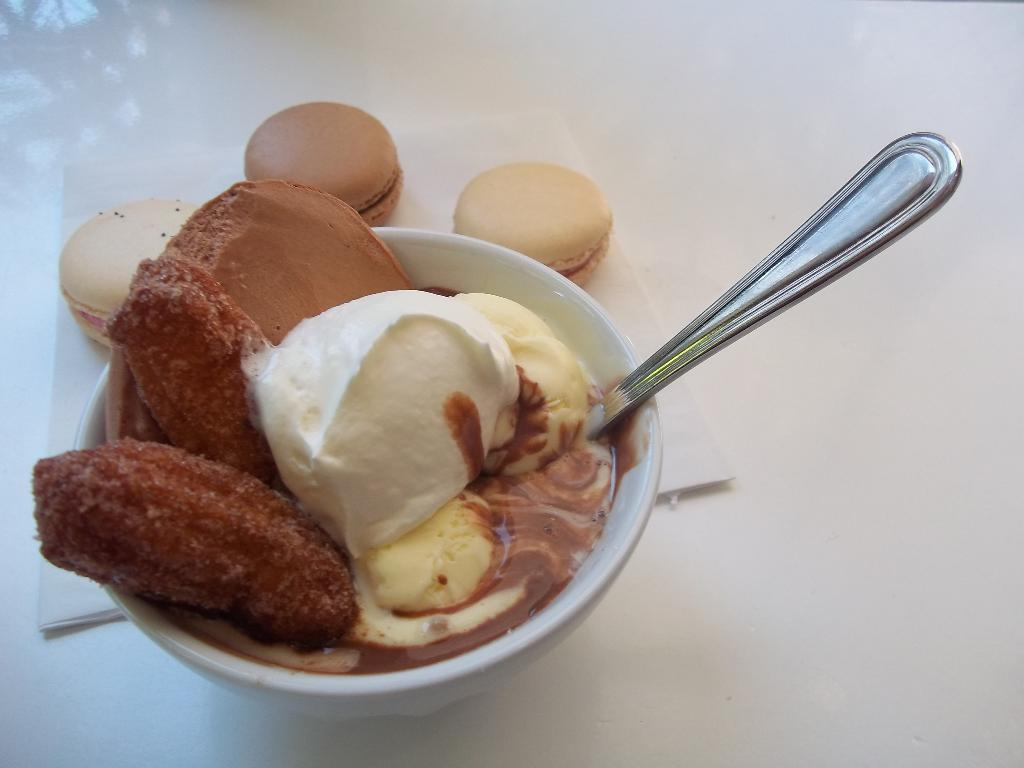What is in the bowl on the white surface in the image? There is a bowl with ice creams and other food items on a white surface. What utensil can be seen in the image? There is a spoon visible in the image. What type of food item is placed on a tissue behind the bowl? There is a tissue with macaroons behind the bowl. What type of connection can be seen between the ice cream and the cherry in the image? There is no cherry present in the image, so there is no connection between the ice cream and a cherry. 